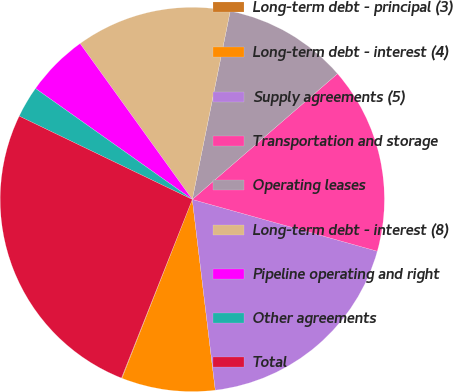Convert chart to OTSL. <chart><loc_0><loc_0><loc_500><loc_500><pie_chart><fcel>Long-term debt - principal (3)<fcel>Long-term debt - interest (4)<fcel>Supply agreements (5)<fcel>Transportation and storage<fcel>Operating leases<fcel>Long-term debt - interest (8)<fcel>Pipeline operating and right<fcel>Other agreements<fcel>Total<nl><fcel>0.05%<fcel>7.87%<fcel>18.75%<fcel>15.7%<fcel>10.48%<fcel>13.09%<fcel>5.27%<fcel>2.66%<fcel>26.13%<nl></chart> 